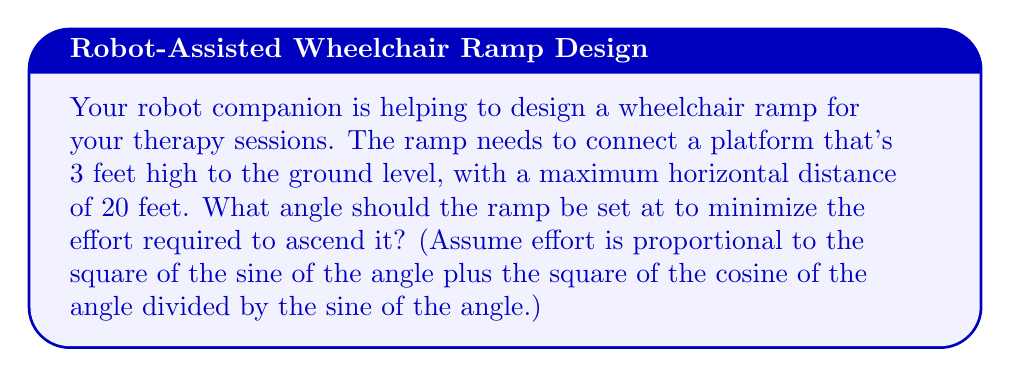Provide a solution to this math problem. Let's approach this step-by-step:

1) Let $\theta$ be the angle of the ramp with the horizontal.

2) The effort function can be written as:

   $$E(\theta) = \sin^2(\theta) + \frac{\cos^2(\theta)}{\sin(\theta)}$$

3) We need to minimize this function. To do so, we'll find where its derivative equals zero.

4) First, let's find the derivative of $E(\theta)$:

   $$E'(\theta) = 2\sin(\theta)\cos(\theta) + \frac{-2\cos^3(\theta)}{\sin^2(\theta)} - \frac{\cos^2(\theta)\cos(\theta)}{\sin^2(\theta)}$$

5) Simplify this expression:

   $$E'(\theta) = 2\sin(\theta)\cos(\theta) - \frac{2\cos^3(\theta) + \cos^3(\theta)}{\sin^2(\theta)}$$
   $$E'(\theta) = 2\sin(\theta)\cos(\theta) - \frac{3\cos^3(\theta)}{\sin^2(\theta)}$$

6) Set this equal to zero and solve:

   $$2\sin(\theta)\cos(\theta) - \frac{3\cos^3(\theta)}{\sin^2(\theta)} = 0$$

7) Multiply both sides by $\sin^2(\theta)$:

   $$2\sin^3(\theta)\cos(\theta) - 3\cos^3(\theta) = 0$$

8) Factor out $\cos(\theta)$:

   $$\cos(\theta)(2\sin^3(\theta) - 3\cos^2(\theta)) = 0$$

9) This is satisfied when either $\cos(\theta) = 0$ or $2\sin^3(\theta) - 3\cos^2(\theta) = 0$

10) $\cos(\theta) = 0$ gives $\theta = 90°$, which isn't practical for a ramp.

11) From $2\sin^3(\theta) - 3\cos^2(\theta) = 0$, we can derive:

    $$\sin(\theta) = \sqrt{\frac{3}{2}} \cos^{2/3}(\theta)$$

12) This gives us $\tan(\theta) = (\frac{3}{2})^{1/4} \approx 1.1447$

13) Therefore, $\theta \approx \arctan(1.1447) \approx 48.8°$

14) We need to verify this angle works with the given dimensions:
    
    $\tan(48.8°) = \frac{3}{x}$, where $x$ is the horizontal distance.
    
    $x = \frac{3}{\tan(48.8°)} \approx 2.62$ feet, which is less than 20 feet, so it's valid.
Answer: $48.8°$ 